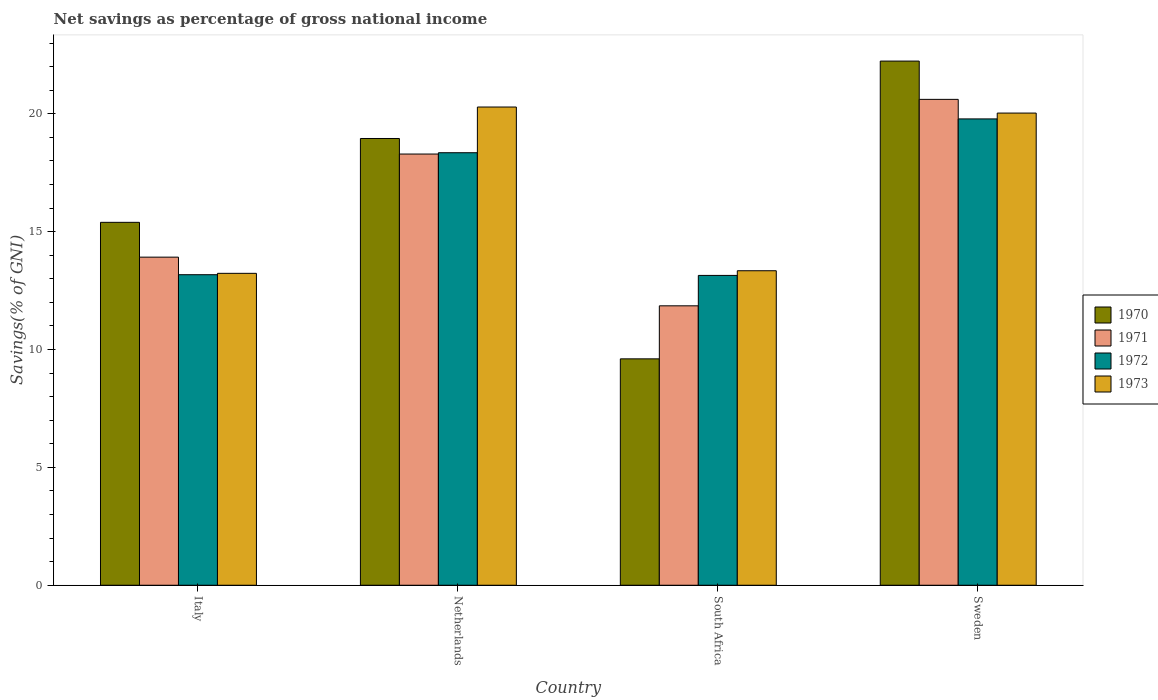How many different coloured bars are there?
Provide a succinct answer. 4. Are the number of bars per tick equal to the number of legend labels?
Keep it short and to the point. Yes. How many bars are there on the 1st tick from the right?
Provide a short and direct response. 4. What is the total savings in 1972 in Sweden?
Offer a terse response. 19.78. Across all countries, what is the maximum total savings in 1973?
Your response must be concise. 20.29. Across all countries, what is the minimum total savings in 1970?
Provide a succinct answer. 9.6. In which country was the total savings in 1972 maximum?
Give a very brief answer. Sweden. In which country was the total savings in 1972 minimum?
Keep it short and to the point. South Africa. What is the total total savings in 1971 in the graph?
Your answer should be compact. 64.68. What is the difference between the total savings in 1971 in Netherlands and that in Sweden?
Your response must be concise. -2.32. What is the difference between the total savings in 1971 in Italy and the total savings in 1970 in Netherlands?
Offer a terse response. -5.03. What is the average total savings in 1970 per country?
Offer a terse response. 16.55. What is the difference between the total savings of/in 1971 and total savings of/in 1972 in Sweden?
Ensure brevity in your answer.  0.83. What is the ratio of the total savings in 1971 in Netherlands to that in South Africa?
Offer a very short reply. 1.54. Is the difference between the total savings in 1971 in Italy and Netherlands greater than the difference between the total savings in 1972 in Italy and Netherlands?
Offer a very short reply. Yes. What is the difference between the highest and the second highest total savings in 1970?
Offer a very short reply. -3.28. What is the difference between the highest and the lowest total savings in 1971?
Give a very brief answer. 8.76. Is the sum of the total savings in 1973 in South Africa and Sweden greater than the maximum total savings in 1971 across all countries?
Ensure brevity in your answer.  Yes. Is it the case that in every country, the sum of the total savings in 1970 and total savings in 1973 is greater than the sum of total savings in 1972 and total savings in 1971?
Ensure brevity in your answer.  No. Is it the case that in every country, the sum of the total savings in 1971 and total savings in 1973 is greater than the total savings in 1972?
Your answer should be compact. Yes. Are all the bars in the graph horizontal?
Provide a short and direct response. No. Does the graph contain any zero values?
Your answer should be very brief. No. What is the title of the graph?
Offer a very short reply. Net savings as percentage of gross national income. Does "1997" appear as one of the legend labels in the graph?
Your answer should be very brief. No. What is the label or title of the X-axis?
Give a very brief answer. Country. What is the label or title of the Y-axis?
Give a very brief answer. Savings(% of GNI). What is the Savings(% of GNI) of 1970 in Italy?
Your answer should be very brief. 15.4. What is the Savings(% of GNI) of 1971 in Italy?
Your answer should be very brief. 13.92. What is the Savings(% of GNI) of 1972 in Italy?
Give a very brief answer. 13.17. What is the Savings(% of GNI) in 1973 in Italy?
Offer a very short reply. 13.23. What is the Savings(% of GNI) in 1970 in Netherlands?
Provide a succinct answer. 18.95. What is the Savings(% of GNI) of 1971 in Netherlands?
Offer a terse response. 18.29. What is the Savings(% of GNI) in 1972 in Netherlands?
Ensure brevity in your answer.  18.35. What is the Savings(% of GNI) in 1973 in Netherlands?
Offer a terse response. 20.29. What is the Savings(% of GNI) in 1970 in South Africa?
Give a very brief answer. 9.6. What is the Savings(% of GNI) of 1971 in South Africa?
Give a very brief answer. 11.85. What is the Savings(% of GNI) of 1972 in South Africa?
Offer a very short reply. 13.14. What is the Savings(% of GNI) of 1973 in South Africa?
Your response must be concise. 13.34. What is the Savings(% of GNI) of 1970 in Sweden?
Your answer should be compact. 22.24. What is the Savings(% of GNI) in 1971 in Sweden?
Your answer should be very brief. 20.61. What is the Savings(% of GNI) in 1972 in Sweden?
Give a very brief answer. 19.78. What is the Savings(% of GNI) of 1973 in Sweden?
Ensure brevity in your answer.  20.03. Across all countries, what is the maximum Savings(% of GNI) of 1970?
Give a very brief answer. 22.24. Across all countries, what is the maximum Savings(% of GNI) of 1971?
Provide a succinct answer. 20.61. Across all countries, what is the maximum Savings(% of GNI) of 1972?
Your answer should be compact. 19.78. Across all countries, what is the maximum Savings(% of GNI) of 1973?
Provide a succinct answer. 20.29. Across all countries, what is the minimum Savings(% of GNI) of 1970?
Give a very brief answer. 9.6. Across all countries, what is the minimum Savings(% of GNI) of 1971?
Make the answer very short. 11.85. Across all countries, what is the minimum Savings(% of GNI) in 1972?
Your answer should be compact. 13.14. Across all countries, what is the minimum Savings(% of GNI) in 1973?
Your answer should be compact. 13.23. What is the total Savings(% of GNI) of 1970 in the graph?
Offer a very short reply. 66.19. What is the total Savings(% of GNI) in 1971 in the graph?
Your response must be concise. 64.68. What is the total Savings(% of GNI) of 1972 in the graph?
Ensure brevity in your answer.  64.45. What is the total Savings(% of GNI) of 1973 in the graph?
Your answer should be compact. 66.89. What is the difference between the Savings(% of GNI) in 1970 in Italy and that in Netherlands?
Make the answer very short. -3.56. What is the difference between the Savings(% of GNI) in 1971 in Italy and that in Netherlands?
Provide a short and direct response. -4.37. What is the difference between the Savings(% of GNI) of 1972 in Italy and that in Netherlands?
Offer a terse response. -5.18. What is the difference between the Savings(% of GNI) in 1973 in Italy and that in Netherlands?
Ensure brevity in your answer.  -7.06. What is the difference between the Savings(% of GNI) of 1970 in Italy and that in South Africa?
Make the answer very short. 5.79. What is the difference between the Savings(% of GNI) of 1971 in Italy and that in South Africa?
Provide a short and direct response. 2.07. What is the difference between the Savings(% of GNI) in 1972 in Italy and that in South Africa?
Your answer should be very brief. 0.03. What is the difference between the Savings(% of GNI) in 1973 in Italy and that in South Africa?
Your answer should be compact. -0.11. What is the difference between the Savings(% of GNI) in 1970 in Italy and that in Sweden?
Ensure brevity in your answer.  -6.84. What is the difference between the Savings(% of GNI) of 1971 in Italy and that in Sweden?
Give a very brief answer. -6.69. What is the difference between the Savings(% of GNI) of 1972 in Italy and that in Sweden?
Your answer should be compact. -6.61. What is the difference between the Savings(% of GNI) of 1973 in Italy and that in Sweden?
Your response must be concise. -6.8. What is the difference between the Savings(% of GNI) in 1970 in Netherlands and that in South Africa?
Your response must be concise. 9.35. What is the difference between the Savings(% of GNI) of 1971 in Netherlands and that in South Africa?
Your answer should be compact. 6.44. What is the difference between the Savings(% of GNI) in 1972 in Netherlands and that in South Africa?
Offer a very short reply. 5.21. What is the difference between the Savings(% of GNI) of 1973 in Netherlands and that in South Africa?
Provide a succinct answer. 6.95. What is the difference between the Savings(% of GNI) in 1970 in Netherlands and that in Sweden?
Offer a very short reply. -3.28. What is the difference between the Savings(% of GNI) in 1971 in Netherlands and that in Sweden?
Make the answer very short. -2.32. What is the difference between the Savings(% of GNI) in 1972 in Netherlands and that in Sweden?
Ensure brevity in your answer.  -1.43. What is the difference between the Savings(% of GNI) in 1973 in Netherlands and that in Sweden?
Provide a short and direct response. 0.26. What is the difference between the Savings(% of GNI) of 1970 in South Africa and that in Sweden?
Keep it short and to the point. -12.63. What is the difference between the Savings(% of GNI) of 1971 in South Africa and that in Sweden?
Give a very brief answer. -8.76. What is the difference between the Savings(% of GNI) in 1972 in South Africa and that in Sweden?
Your answer should be compact. -6.64. What is the difference between the Savings(% of GNI) in 1973 in South Africa and that in Sweden?
Offer a terse response. -6.69. What is the difference between the Savings(% of GNI) in 1970 in Italy and the Savings(% of GNI) in 1971 in Netherlands?
Offer a terse response. -2.9. What is the difference between the Savings(% of GNI) in 1970 in Italy and the Savings(% of GNI) in 1972 in Netherlands?
Ensure brevity in your answer.  -2.95. What is the difference between the Savings(% of GNI) of 1970 in Italy and the Savings(% of GNI) of 1973 in Netherlands?
Give a very brief answer. -4.89. What is the difference between the Savings(% of GNI) in 1971 in Italy and the Savings(% of GNI) in 1972 in Netherlands?
Give a very brief answer. -4.43. What is the difference between the Savings(% of GNI) in 1971 in Italy and the Savings(% of GNI) in 1973 in Netherlands?
Make the answer very short. -6.37. What is the difference between the Savings(% of GNI) of 1972 in Italy and the Savings(% of GNI) of 1973 in Netherlands?
Provide a short and direct response. -7.11. What is the difference between the Savings(% of GNI) in 1970 in Italy and the Savings(% of GNI) in 1971 in South Africa?
Make the answer very short. 3.54. What is the difference between the Savings(% of GNI) of 1970 in Italy and the Savings(% of GNI) of 1972 in South Africa?
Offer a very short reply. 2.25. What is the difference between the Savings(% of GNI) of 1970 in Italy and the Savings(% of GNI) of 1973 in South Africa?
Your answer should be compact. 2.05. What is the difference between the Savings(% of GNI) in 1971 in Italy and the Savings(% of GNI) in 1972 in South Africa?
Make the answer very short. 0.78. What is the difference between the Savings(% of GNI) of 1971 in Italy and the Savings(% of GNI) of 1973 in South Africa?
Make the answer very short. 0.58. What is the difference between the Savings(% of GNI) of 1972 in Italy and the Savings(% of GNI) of 1973 in South Africa?
Make the answer very short. -0.17. What is the difference between the Savings(% of GNI) of 1970 in Italy and the Savings(% of GNI) of 1971 in Sweden?
Your answer should be very brief. -5.22. What is the difference between the Savings(% of GNI) in 1970 in Italy and the Savings(% of GNI) in 1972 in Sweden?
Offer a terse response. -4.39. What is the difference between the Savings(% of GNI) of 1970 in Italy and the Savings(% of GNI) of 1973 in Sweden?
Offer a very short reply. -4.64. What is the difference between the Savings(% of GNI) in 1971 in Italy and the Savings(% of GNI) in 1972 in Sweden?
Keep it short and to the point. -5.86. What is the difference between the Savings(% of GNI) of 1971 in Italy and the Savings(% of GNI) of 1973 in Sweden?
Make the answer very short. -6.11. What is the difference between the Savings(% of GNI) in 1972 in Italy and the Savings(% of GNI) in 1973 in Sweden?
Keep it short and to the point. -6.86. What is the difference between the Savings(% of GNI) in 1970 in Netherlands and the Savings(% of GNI) in 1971 in South Africa?
Offer a very short reply. 7.1. What is the difference between the Savings(% of GNI) of 1970 in Netherlands and the Savings(% of GNI) of 1972 in South Africa?
Provide a short and direct response. 5.81. What is the difference between the Savings(% of GNI) in 1970 in Netherlands and the Savings(% of GNI) in 1973 in South Africa?
Give a very brief answer. 5.61. What is the difference between the Savings(% of GNI) in 1971 in Netherlands and the Savings(% of GNI) in 1972 in South Africa?
Offer a very short reply. 5.15. What is the difference between the Savings(% of GNI) of 1971 in Netherlands and the Savings(% of GNI) of 1973 in South Africa?
Make the answer very short. 4.95. What is the difference between the Savings(% of GNI) of 1972 in Netherlands and the Savings(% of GNI) of 1973 in South Africa?
Offer a very short reply. 5.01. What is the difference between the Savings(% of GNI) of 1970 in Netherlands and the Savings(% of GNI) of 1971 in Sweden?
Make the answer very short. -1.66. What is the difference between the Savings(% of GNI) in 1970 in Netherlands and the Savings(% of GNI) in 1972 in Sweden?
Provide a short and direct response. -0.83. What is the difference between the Savings(% of GNI) of 1970 in Netherlands and the Savings(% of GNI) of 1973 in Sweden?
Ensure brevity in your answer.  -1.08. What is the difference between the Savings(% of GNI) in 1971 in Netherlands and the Savings(% of GNI) in 1972 in Sweden?
Ensure brevity in your answer.  -1.49. What is the difference between the Savings(% of GNI) in 1971 in Netherlands and the Savings(% of GNI) in 1973 in Sweden?
Make the answer very short. -1.74. What is the difference between the Savings(% of GNI) in 1972 in Netherlands and the Savings(% of GNI) in 1973 in Sweden?
Ensure brevity in your answer.  -1.68. What is the difference between the Savings(% of GNI) in 1970 in South Africa and the Savings(% of GNI) in 1971 in Sweden?
Offer a terse response. -11.01. What is the difference between the Savings(% of GNI) of 1970 in South Africa and the Savings(% of GNI) of 1972 in Sweden?
Make the answer very short. -10.18. What is the difference between the Savings(% of GNI) of 1970 in South Africa and the Savings(% of GNI) of 1973 in Sweden?
Give a very brief answer. -10.43. What is the difference between the Savings(% of GNI) of 1971 in South Africa and the Savings(% of GNI) of 1972 in Sweden?
Make the answer very short. -7.93. What is the difference between the Savings(% of GNI) in 1971 in South Africa and the Savings(% of GNI) in 1973 in Sweden?
Your answer should be compact. -8.18. What is the difference between the Savings(% of GNI) in 1972 in South Africa and the Savings(% of GNI) in 1973 in Sweden?
Provide a short and direct response. -6.89. What is the average Savings(% of GNI) of 1970 per country?
Ensure brevity in your answer.  16.55. What is the average Savings(% of GNI) in 1971 per country?
Provide a short and direct response. 16.17. What is the average Savings(% of GNI) of 1972 per country?
Your answer should be compact. 16.11. What is the average Savings(% of GNI) in 1973 per country?
Make the answer very short. 16.72. What is the difference between the Savings(% of GNI) of 1970 and Savings(% of GNI) of 1971 in Italy?
Your answer should be very brief. 1.48. What is the difference between the Savings(% of GNI) in 1970 and Savings(% of GNI) in 1972 in Italy?
Give a very brief answer. 2.22. What is the difference between the Savings(% of GNI) of 1970 and Savings(% of GNI) of 1973 in Italy?
Provide a short and direct response. 2.16. What is the difference between the Savings(% of GNI) of 1971 and Savings(% of GNI) of 1972 in Italy?
Your response must be concise. 0.75. What is the difference between the Savings(% of GNI) of 1971 and Savings(% of GNI) of 1973 in Italy?
Your answer should be very brief. 0.69. What is the difference between the Savings(% of GNI) of 1972 and Savings(% of GNI) of 1973 in Italy?
Make the answer very short. -0.06. What is the difference between the Savings(% of GNI) of 1970 and Savings(% of GNI) of 1971 in Netherlands?
Give a very brief answer. 0.66. What is the difference between the Savings(% of GNI) in 1970 and Savings(% of GNI) in 1972 in Netherlands?
Provide a short and direct response. 0.6. What is the difference between the Savings(% of GNI) of 1970 and Savings(% of GNI) of 1973 in Netherlands?
Offer a very short reply. -1.33. What is the difference between the Savings(% of GNI) of 1971 and Savings(% of GNI) of 1972 in Netherlands?
Make the answer very short. -0.06. What is the difference between the Savings(% of GNI) of 1971 and Savings(% of GNI) of 1973 in Netherlands?
Provide a succinct answer. -1.99. What is the difference between the Savings(% of GNI) of 1972 and Savings(% of GNI) of 1973 in Netherlands?
Your answer should be very brief. -1.94. What is the difference between the Savings(% of GNI) in 1970 and Savings(% of GNI) in 1971 in South Africa?
Provide a short and direct response. -2.25. What is the difference between the Savings(% of GNI) in 1970 and Savings(% of GNI) in 1972 in South Africa?
Ensure brevity in your answer.  -3.54. What is the difference between the Savings(% of GNI) of 1970 and Savings(% of GNI) of 1973 in South Africa?
Your answer should be very brief. -3.74. What is the difference between the Savings(% of GNI) of 1971 and Savings(% of GNI) of 1972 in South Africa?
Your response must be concise. -1.29. What is the difference between the Savings(% of GNI) in 1971 and Savings(% of GNI) in 1973 in South Africa?
Ensure brevity in your answer.  -1.49. What is the difference between the Savings(% of GNI) in 1972 and Savings(% of GNI) in 1973 in South Africa?
Your answer should be compact. -0.2. What is the difference between the Savings(% of GNI) of 1970 and Savings(% of GNI) of 1971 in Sweden?
Offer a terse response. 1.62. What is the difference between the Savings(% of GNI) in 1970 and Savings(% of GNI) in 1972 in Sweden?
Your answer should be very brief. 2.45. What is the difference between the Savings(% of GNI) in 1970 and Savings(% of GNI) in 1973 in Sweden?
Keep it short and to the point. 2.21. What is the difference between the Savings(% of GNI) of 1971 and Savings(% of GNI) of 1972 in Sweden?
Keep it short and to the point. 0.83. What is the difference between the Savings(% of GNI) of 1971 and Savings(% of GNI) of 1973 in Sweden?
Your response must be concise. 0.58. What is the difference between the Savings(% of GNI) of 1972 and Savings(% of GNI) of 1973 in Sweden?
Your response must be concise. -0.25. What is the ratio of the Savings(% of GNI) in 1970 in Italy to that in Netherlands?
Your answer should be compact. 0.81. What is the ratio of the Savings(% of GNI) of 1971 in Italy to that in Netherlands?
Provide a succinct answer. 0.76. What is the ratio of the Savings(% of GNI) in 1972 in Italy to that in Netherlands?
Offer a terse response. 0.72. What is the ratio of the Savings(% of GNI) of 1973 in Italy to that in Netherlands?
Your answer should be compact. 0.65. What is the ratio of the Savings(% of GNI) of 1970 in Italy to that in South Africa?
Ensure brevity in your answer.  1.6. What is the ratio of the Savings(% of GNI) of 1971 in Italy to that in South Africa?
Offer a terse response. 1.17. What is the ratio of the Savings(% of GNI) of 1972 in Italy to that in South Africa?
Ensure brevity in your answer.  1. What is the ratio of the Savings(% of GNI) of 1970 in Italy to that in Sweden?
Your response must be concise. 0.69. What is the ratio of the Savings(% of GNI) of 1971 in Italy to that in Sweden?
Offer a terse response. 0.68. What is the ratio of the Savings(% of GNI) in 1972 in Italy to that in Sweden?
Make the answer very short. 0.67. What is the ratio of the Savings(% of GNI) of 1973 in Italy to that in Sweden?
Make the answer very short. 0.66. What is the ratio of the Savings(% of GNI) of 1970 in Netherlands to that in South Africa?
Your answer should be very brief. 1.97. What is the ratio of the Savings(% of GNI) in 1971 in Netherlands to that in South Africa?
Provide a succinct answer. 1.54. What is the ratio of the Savings(% of GNI) in 1972 in Netherlands to that in South Africa?
Offer a very short reply. 1.4. What is the ratio of the Savings(% of GNI) in 1973 in Netherlands to that in South Africa?
Your answer should be compact. 1.52. What is the ratio of the Savings(% of GNI) of 1970 in Netherlands to that in Sweden?
Make the answer very short. 0.85. What is the ratio of the Savings(% of GNI) in 1971 in Netherlands to that in Sweden?
Provide a succinct answer. 0.89. What is the ratio of the Savings(% of GNI) in 1972 in Netherlands to that in Sweden?
Offer a very short reply. 0.93. What is the ratio of the Savings(% of GNI) of 1973 in Netherlands to that in Sweden?
Your response must be concise. 1.01. What is the ratio of the Savings(% of GNI) in 1970 in South Africa to that in Sweden?
Your response must be concise. 0.43. What is the ratio of the Savings(% of GNI) in 1971 in South Africa to that in Sweden?
Your answer should be compact. 0.58. What is the ratio of the Savings(% of GNI) of 1972 in South Africa to that in Sweden?
Offer a very short reply. 0.66. What is the ratio of the Savings(% of GNI) in 1973 in South Africa to that in Sweden?
Ensure brevity in your answer.  0.67. What is the difference between the highest and the second highest Savings(% of GNI) in 1970?
Your answer should be very brief. 3.28. What is the difference between the highest and the second highest Savings(% of GNI) in 1971?
Your answer should be very brief. 2.32. What is the difference between the highest and the second highest Savings(% of GNI) of 1972?
Ensure brevity in your answer.  1.43. What is the difference between the highest and the second highest Savings(% of GNI) of 1973?
Offer a terse response. 0.26. What is the difference between the highest and the lowest Savings(% of GNI) of 1970?
Your response must be concise. 12.63. What is the difference between the highest and the lowest Savings(% of GNI) in 1971?
Provide a short and direct response. 8.76. What is the difference between the highest and the lowest Savings(% of GNI) of 1972?
Provide a short and direct response. 6.64. What is the difference between the highest and the lowest Savings(% of GNI) of 1973?
Provide a short and direct response. 7.06. 